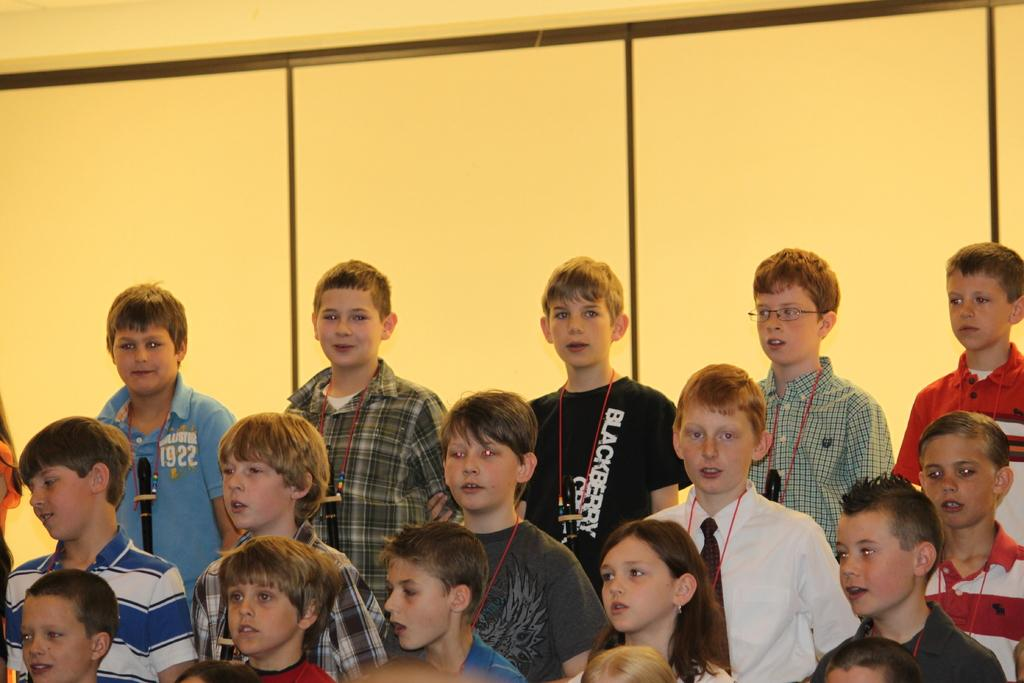How many people are in the image? There are fifteen people in the image, fourteen boys and one girl. What are the boys and girl doing in the image? The boys and girl are standing. What can be seen behind the boys and girl in the image? There is a wall visible in the image. What is the color of the wall? The wall is cream in color. What type of lizards can be seen climbing the wall in the image? There are no lizards present in the image; it only features boys, a girl, and a wall. 